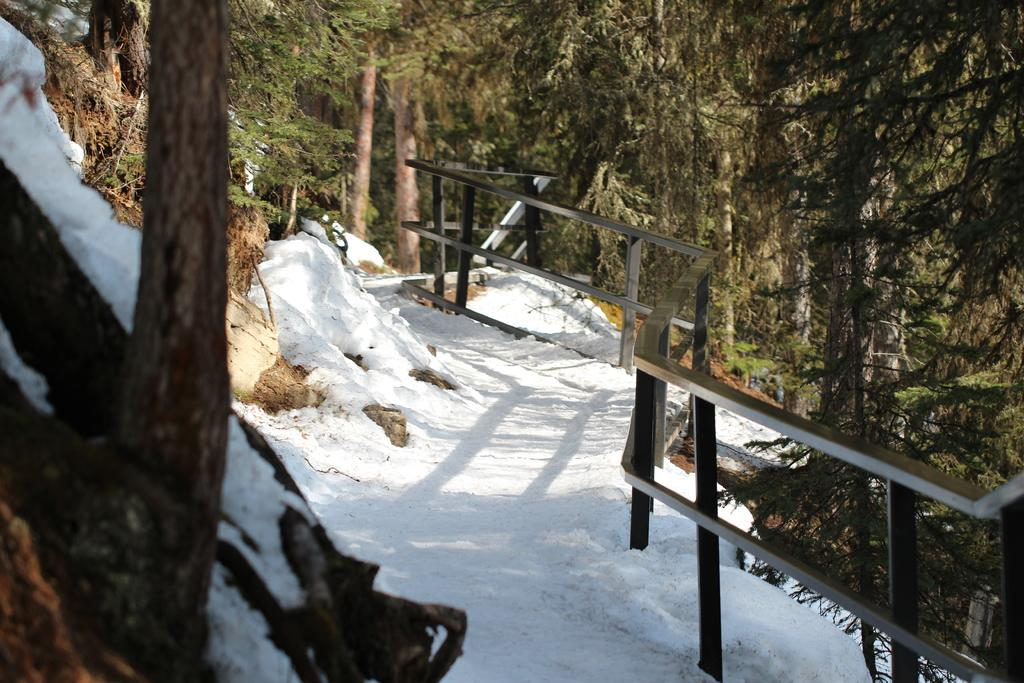What type of weather is depicted in the image? There is snow on the way in the image, indicating a snowy or wintry scene. What type of vegetation can be seen in the image? There are green trees in the image. What type of sack is being used to play chess in the image? There is no sack or chess game present in the image. What type of request is being made by the trees in the image? There are no requests being made by the trees in the image. 